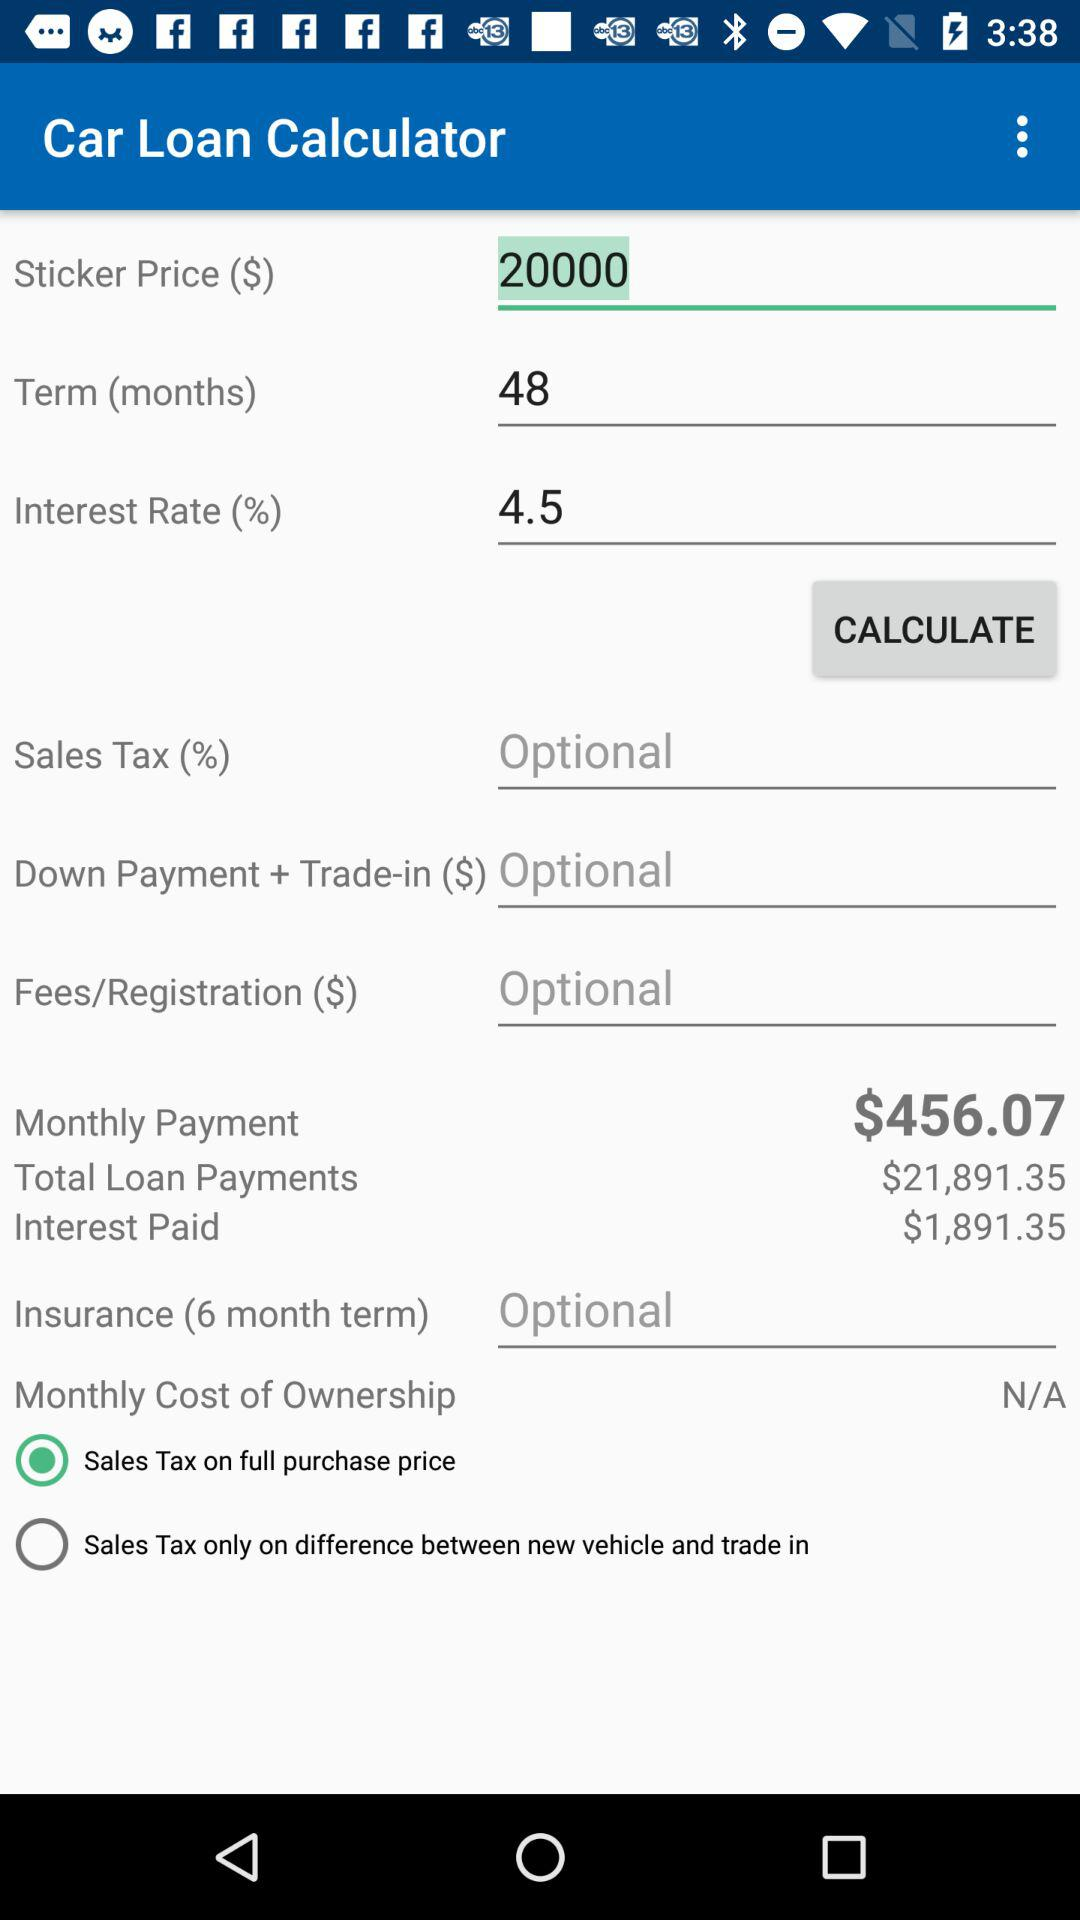What is the status of the "Sales Tax only on difference between new vehicle and trade in"? The status is off. 